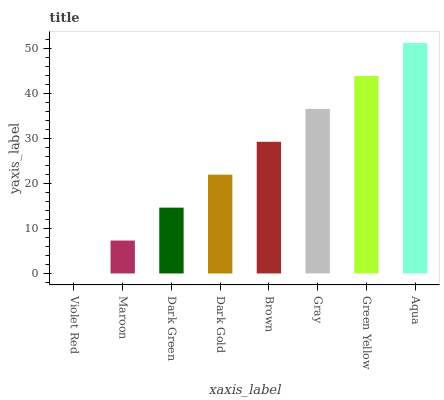Is Violet Red the minimum?
Answer yes or no. Yes. Is Aqua the maximum?
Answer yes or no. Yes. Is Maroon the minimum?
Answer yes or no. No. Is Maroon the maximum?
Answer yes or no. No. Is Maroon greater than Violet Red?
Answer yes or no. Yes. Is Violet Red less than Maroon?
Answer yes or no. Yes. Is Violet Red greater than Maroon?
Answer yes or no. No. Is Maroon less than Violet Red?
Answer yes or no. No. Is Brown the high median?
Answer yes or no. Yes. Is Dark Gold the low median?
Answer yes or no. Yes. Is Maroon the high median?
Answer yes or no. No. Is Gray the low median?
Answer yes or no. No. 